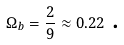<formula> <loc_0><loc_0><loc_500><loc_500>\Omega _ { b } = \frac { 2 } { 9 } \approx 0 . 2 2 \ \text {.}</formula> 